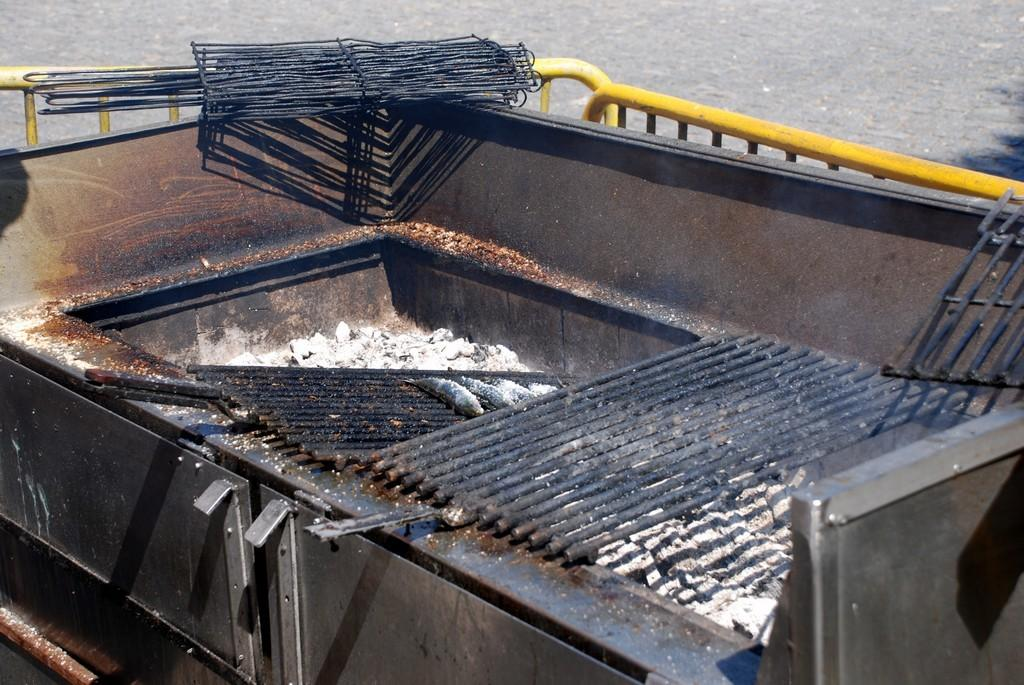What is the main subject of the image? The main subject of the image is an outdoor grill rack. What can be seen in the background of the image? There are grilles and a road visible in the background of the image. What type of shop can be seen in the image? There is no shop present in the image; it features an outdoor grill rack and a background with grilles and a road. 